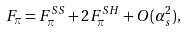<formula> <loc_0><loc_0><loc_500><loc_500>F _ { \pi } = F ^ { S S } _ { \pi } + 2 F ^ { S H } _ { \pi } + O ( \alpha ^ { 2 } _ { s } ) ,</formula> 